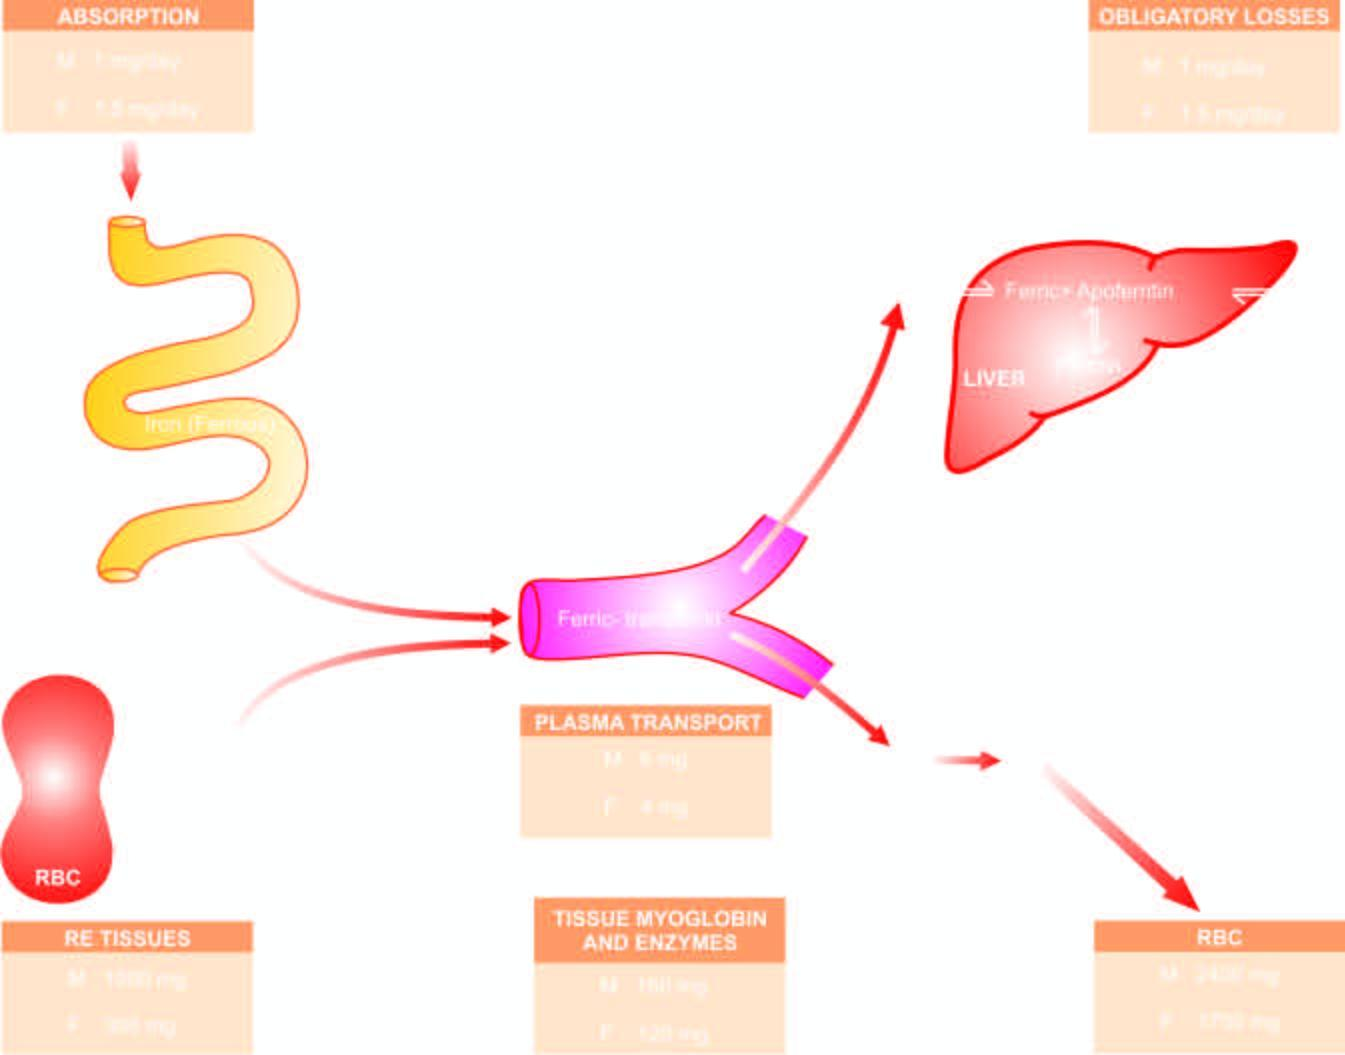what circulates in plasma bound to transferrin and is transported to the bone marrow for utilisation in haemoglobin synthesis?
Answer the question using a single word or phrase. Iron on absorption from upper small intestine 